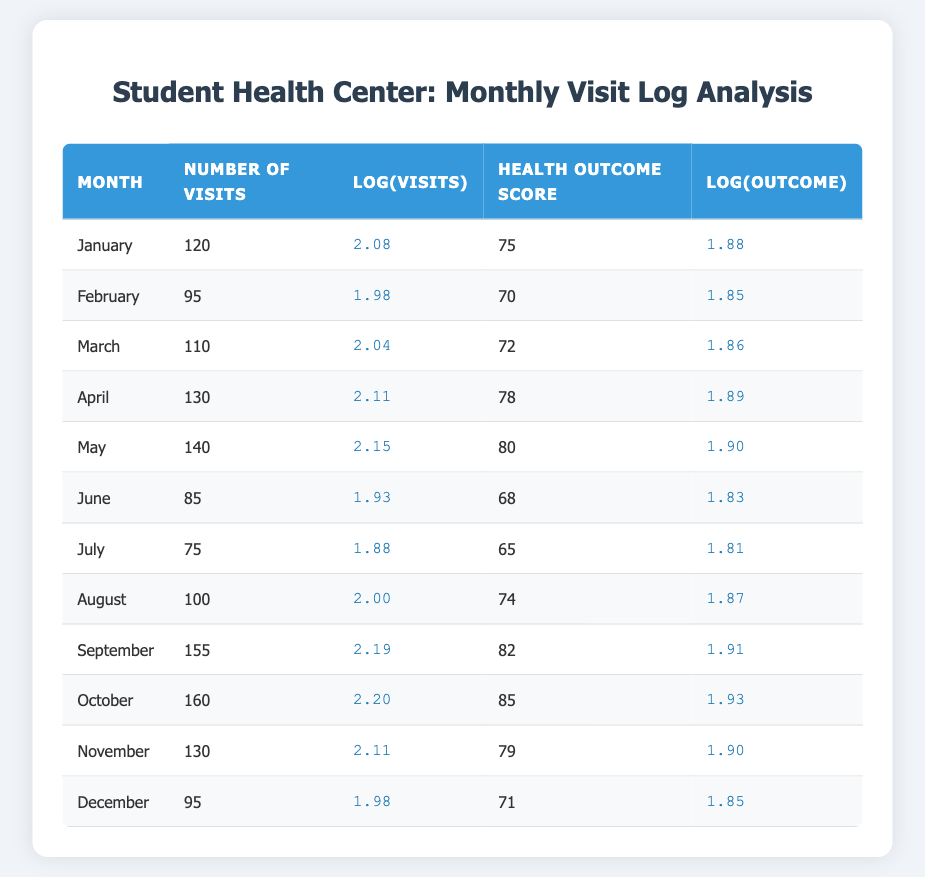What month had the highest number of visits? Looking at the number of visits column, September has the highest value of 155 visits.
Answer: September What was the health outcome score for April? The health outcome score for April is directly listed in the table as 78.
Answer: 78 Which month experienced the lowest health outcome score, and what was that score? By inspecting the health outcome scores for each month, July has the lowest score of 65.
Answer: July, 65 What is the average number of visits for the months with health outcome scores above 75? The months with health outcome scores above 75 are May (140), September (155), October (160), and April (130). Summing those gives 140 + 155 + 160 + 130 = 585. There are 4 months, so the average is 585 / 4 = 146.25.
Answer: 146.25 Is it true that the logarithmic value of visits for June is greater than that of July? The logarithmic value for June is 1.93 and for July is 1.88. Since 1.93 > 1.88, it is true.
Answer: True What is the difference in health outcome scores between the months with the highest and lowest number of visits? The month with the highest number of visits (September) has a health outcome score of 82, and the month with the lowest visits (July) has a score of 65. The difference is 82 - 65 = 17.
Answer: 17 Which month had a health outcome score higher than 80? The months with health outcome scores higher than 80 are May (80), September (82), and October (85).
Answer: May, September, October What is the median of the health outcome scores for the months listed? The health outcome scores in order are 65, 68, 70, 71, 72, 75, 78, 79, 80, 82, 85. The median is the average of the 6th and 7th scores which are 75 and 78. Thus, the median is (75 + 78) / 2 = 76.5.
Answer: 76.5 